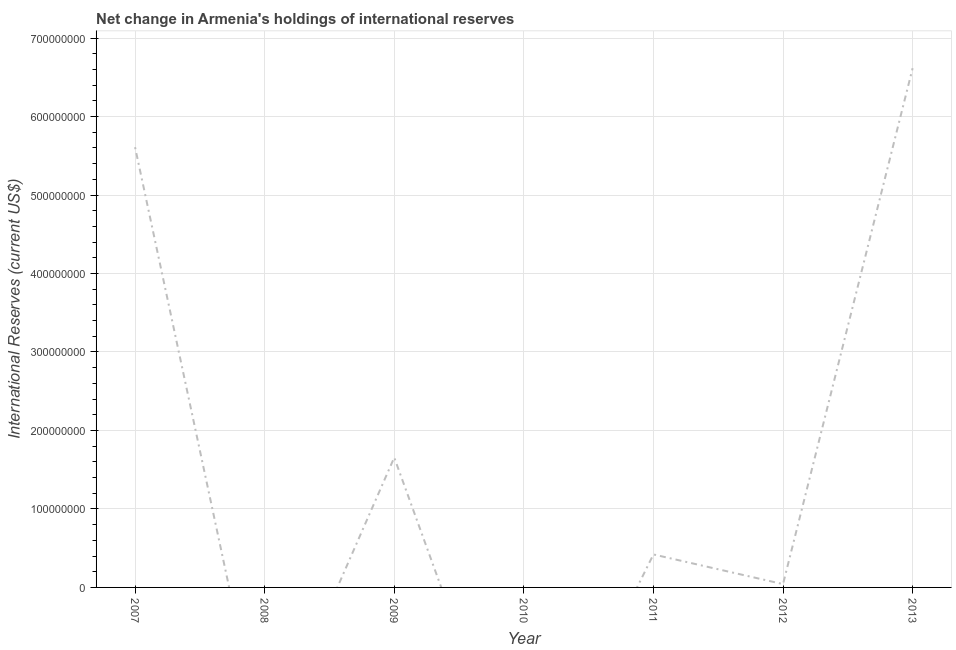Across all years, what is the maximum reserves and related items?
Your answer should be compact. 6.62e+08. Across all years, what is the minimum reserves and related items?
Give a very brief answer. 0. In which year was the reserves and related items maximum?
Offer a very short reply. 2013. What is the sum of the reserves and related items?
Make the answer very short. 1.43e+09. What is the difference between the reserves and related items in 2011 and 2012?
Keep it short and to the point. 3.78e+07. What is the average reserves and related items per year?
Offer a terse response. 2.05e+08. What is the median reserves and related items?
Offer a very short reply. 4.20e+07. In how many years, is the reserves and related items greater than 680000000 US$?
Offer a terse response. 0. What is the ratio of the reserves and related items in 2011 to that in 2012?
Ensure brevity in your answer.  9.95. Is the reserves and related items in 2009 less than that in 2011?
Give a very brief answer. No. What is the difference between the highest and the second highest reserves and related items?
Your answer should be very brief. 1.01e+08. What is the difference between the highest and the lowest reserves and related items?
Make the answer very short. 6.62e+08. How many lines are there?
Provide a succinct answer. 1. What is the difference between two consecutive major ticks on the Y-axis?
Give a very brief answer. 1.00e+08. Are the values on the major ticks of Y-axis written in scientific E-notation?
Provide a succinct answer. No. What is the title of the graph?
Give a very brief answer. Net change in Armenia's holdings of international reserves. What is the label or title of the X-axis?
Give a very brief answer. Year. What is the label or title of the Y-axis?
Keep it short and to the point. International Reserves (current US$). What is the International Reserves (current US$) in 2007?
Keep it short and to the point. 5.61e+08. What is the International Reserves (current US$) of 2008?
Make the answer very short. 0. What is the International Reserves (current US$) of 2009?
Offer a terse response. 1.66e+08. What is the International Reserves (current US$) in 2010?
Ensure brevity in your answer.  0. What is the International Reserves (current US$) in 2011?
Keep it short and to the point. 4.20e+07. What is the International Reserves (current US$) in 2012?
Ensure brevity in your answer.  4.22e+06. What is the International Reserves (current US$) in 2013?
Your answer should be very brief. 6.62e+08. What is the difference between the International Reserves (current US$) in 2007 and 2009?
Offer a terse response. 3.95e+08. What is the difference between the International Reserves (current US$) in 2007 and 2011?
Offer a terse response. 5.19e+08. What is the difference between the International Reserves (current US$) in 2007 and 2012?
Give a very brief answer. 5.57e+08. What is the difference between the International Reserves (current US$) in 2007 and 2013?
Make the answer very short. -1.01e+08. What is the difference between the International Reserves (current US$) in 2009 and 2011?
Provide a short and direct response. 1.23e+08. What is the difference between the International Reserves (current US$) in 2009 and 2012?
Give a very brief answer. 1.61e+08. What is the difference between the International Reserves (current US$) in 2009 and 2013?
Provide a short and direct response. -4.96e+08. What is the difference between the International Reserves (current US$) in 2011 and 2012?
Offer a very short reply. 3.78e+07. What is the difference between the International Reserves (current US$) in 2011 and 2013?
Your response must be concise. -6.20e+08. What is the difference between the International Reserves (current US$) in 2012 and 2013?
Make the answer very short. -6.57e+08. What is the ratio of the International Reserves (current US$) in 2007 to that in 2009?
Offer a terse response. 3.39. What is the ratio of the International Reserves (current US$) in 2007 to that in 2011?
Offer a very short reply. 13.35. What is the ratio of the International Reserves (current US$) in 2007 to that in 2012?
Provide a short and direct response. 132.83. What is the ratio of the International Reserves (current US$) in 2007 to that in 2013?
Offer a terse response. 0.85. What is the ratio of the International Reserves (current US$) in 2009 to that in 2011?
Offer a terse response. 3.94. What is the ratio of the International Reserves (current US$) in 2009 to that in 2012?
Make the answer very short. 39.19. What is the ratio of the International Reserves (current US$) in 2011 to that in 2012?
Give a very brief answer. 9.95. What is the ratio of the International Reserves (current US$) in 2011 to that in 2013?
Provide a short and direct response. 0.06. What is the ratio of the International Reserves (current US$) in 2012 to that in 2013?
Ensure brevity in your answer.  0.01. 